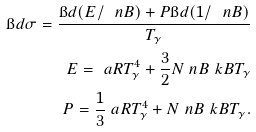<formula> <loc_0><loc_0><loc_500><loc_500>\i d \sigma = \frac { \i d ( E / \ n B ) + P \i d ( 1 / \ n B ) } { T _ { \gamma } } \\ E = \ a R T _ { \gamma } ^ { 4 } + \frac { 3 } { 2 } N \ n B \ k B T _ { \gamma } \\ P = \frac { 1 } { 3 } \ a R T _ { \gamma } ^ { 4 } + N \ n B \ k B T _ { \gamma } { . }</formula> 